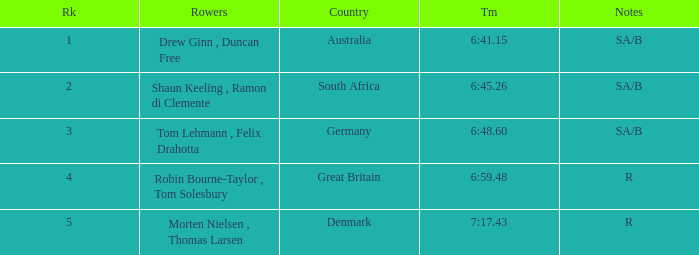What was the highest rank for rowers who represented Denmark? 5.0. 